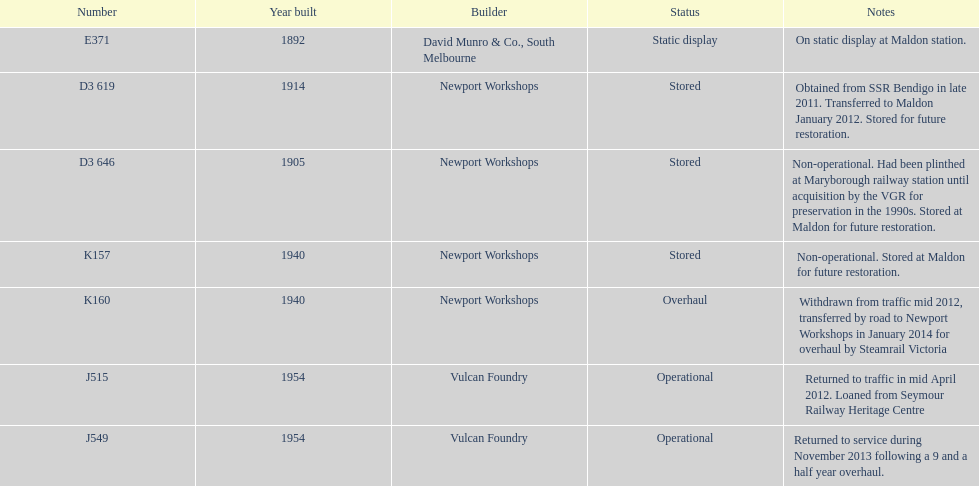Which are the only trains still in service? J515, J549. 